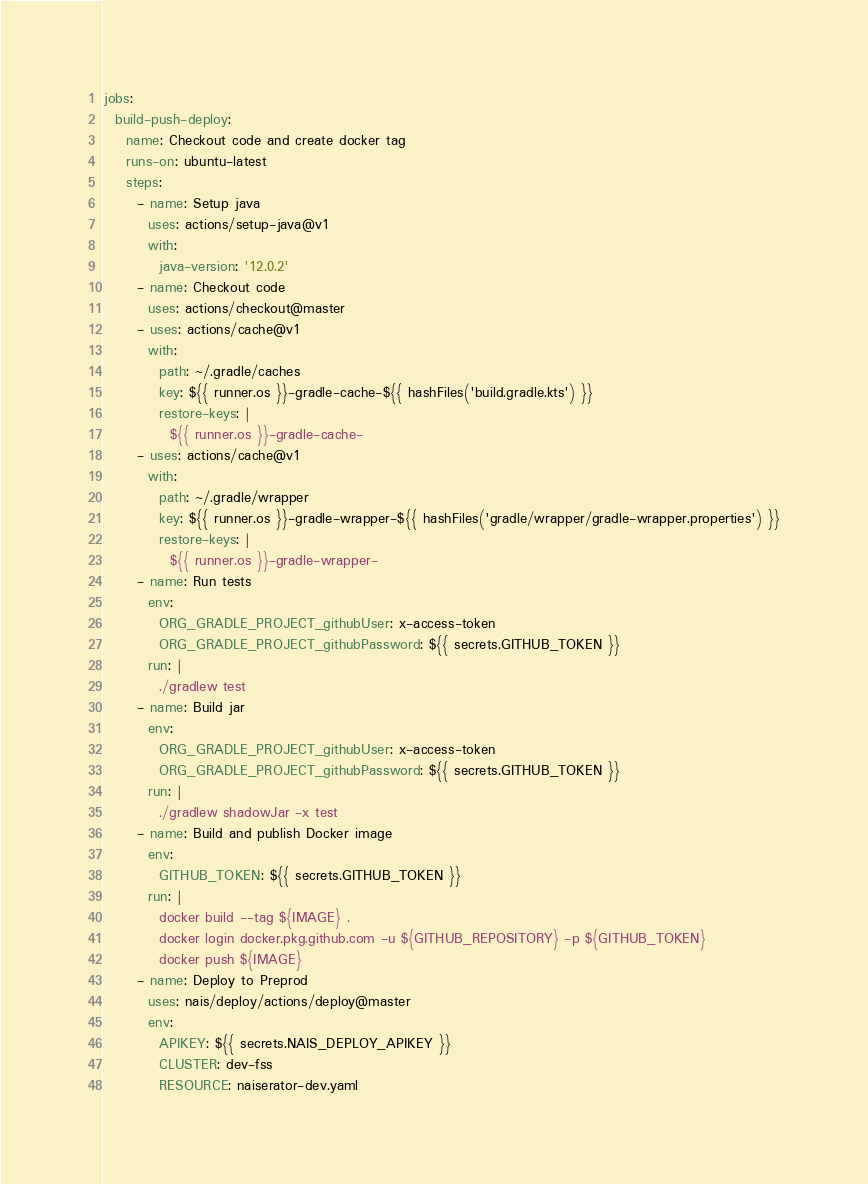Convert code to text. <code><loc_0><loc_0><loc_500><loc_500><_YAML_>
jobs:
  build-push-deploy:
    name: Checkout code and create docker tag
    runs-on: ubuntu-latest
    steps:
      - name: Setup java
        uses: actions/setup-java@v1
        with:
          java-version: '12.0.2'
      - name: Checkout code
        uses: actions/checkout@master
      - uses: actions/cache@v1
        with:
          path: ~/.gradle/caches
          key: ${{ runner.os }}-gradle-cache-${{ hashFiles('build.gradle.kts') }}
          restore-keys: |
            ${{ runner.os }}-gradle-cache-
      - uses: actions/cache@v1
        with:
          path: ~/.gradle/wrapper
          key: ${{ runner.os }}-gradle-wrapper-${{ hashFiles('gradle/wrapper/gradle-wrapper.properties') }}
          restore-keys: |
            ${{ runner.os }}-gradle-wrapper-
      - name: Run tests
        env:
          ORG_GRADLE_PROJECT_githubUser: x-access-token
          ORG_GRADLE_PROJECT_githubPassword: ${{ secrets.GITHUB_TOKEN }}
        run: |
          ./gradlew test
      - name: Build jar
        env:
          ORG_GRADLE_PROJECT_githubUser: x-access-token
          ORG_GRADLE_PROJECT_githubPassword: ${{ secrets.GITHUB_TOKEN }}
        run: |
          ./gradlew shadowJar -x test
      - name: Build and publish Docker image
        env:
          GITHUB_TOKEN: ${{ secrets.GITHUB_TOKEN }}
        run: |
          docker build --tag ${IMAGE} .
          docker login docker.pkg.github.com -u ${GITHUB_REPOSITORY} -p ${GITHUB_TOKEN}
          docker push ${IMAGE}
      - name: Deploy to Preprod
        uses: nais/deploy/actions/deploy@master
        env:
          APIKEY: ${{ secrets.NAIS_DEPLOY_APIKEY }}
          CLUSTER: dev-fss
          RESOURCE: naiserator-dev.yaml</code> 